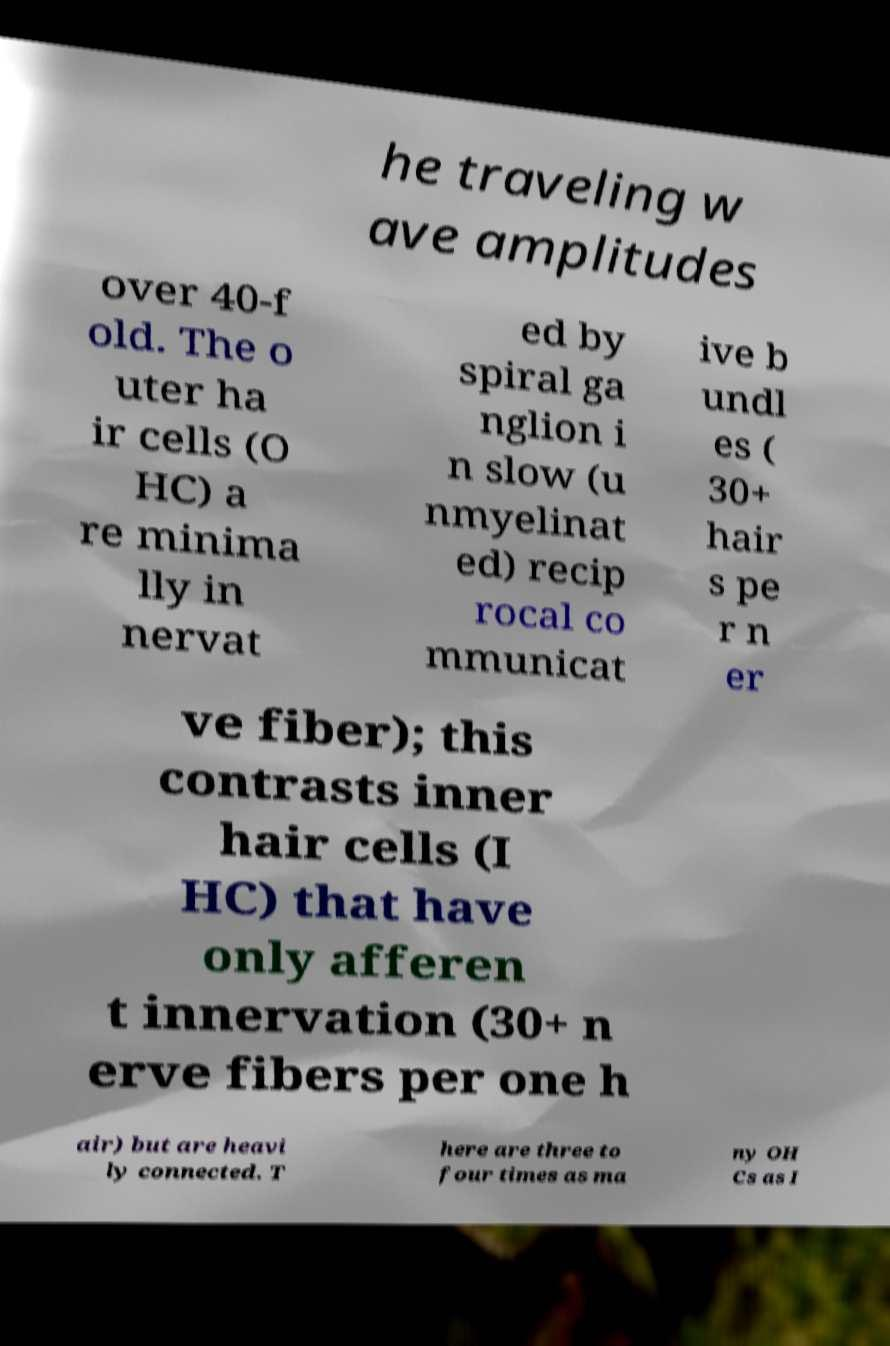Can you accurately transcribe the text from the provided image for me? he traveling w ave amplitudes over 40-f old. The o uter ha ir cells (O HC) a re minima lly in nervat ed by spiral ga nglion i n slow (u nmyelinat ed) recip rocal co mmunicat ive b undl es ( 30+ hair s pe r n er ve fiber); this contrasts inner hair cells (I HC) that have only afferen t innervation (30+ n erve fibers per one h air) but are heavi ly connected. T here are three to four times as ma ny OH Cs as I 